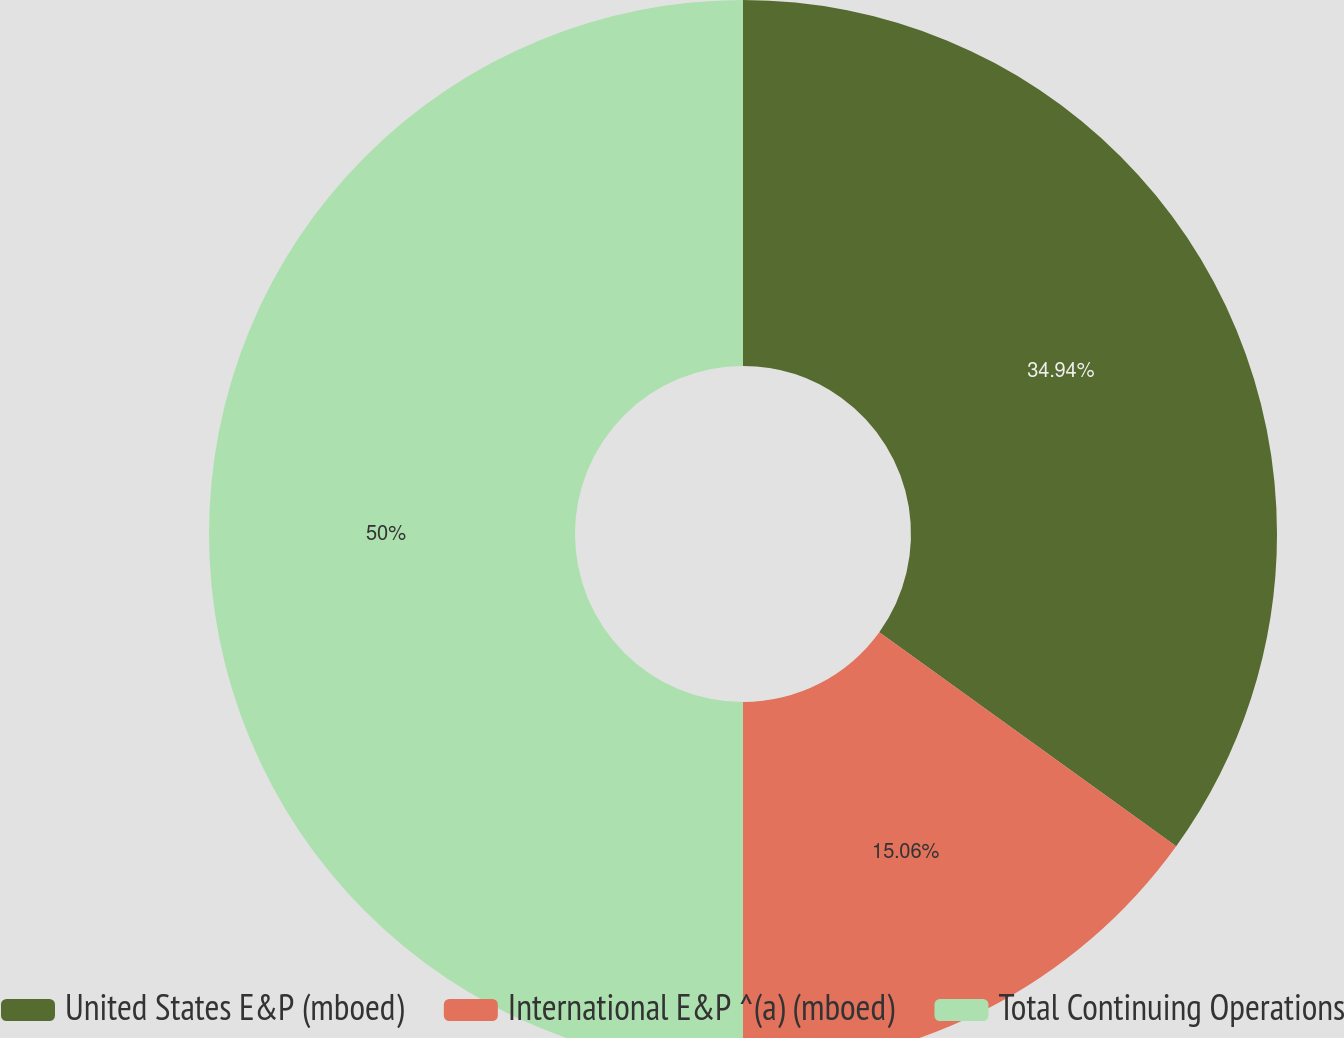<chart> <loc_0><loc_0><loc_500><loc_500><pie_chart><fcel>United States E&P (mboed)<fcel>International E&P ^(a) (mboed)<fcel>Total Continuing Operations<nl><fcel>34.94%<fcel>15.06%<fcel>50.0%<nl></chart> 